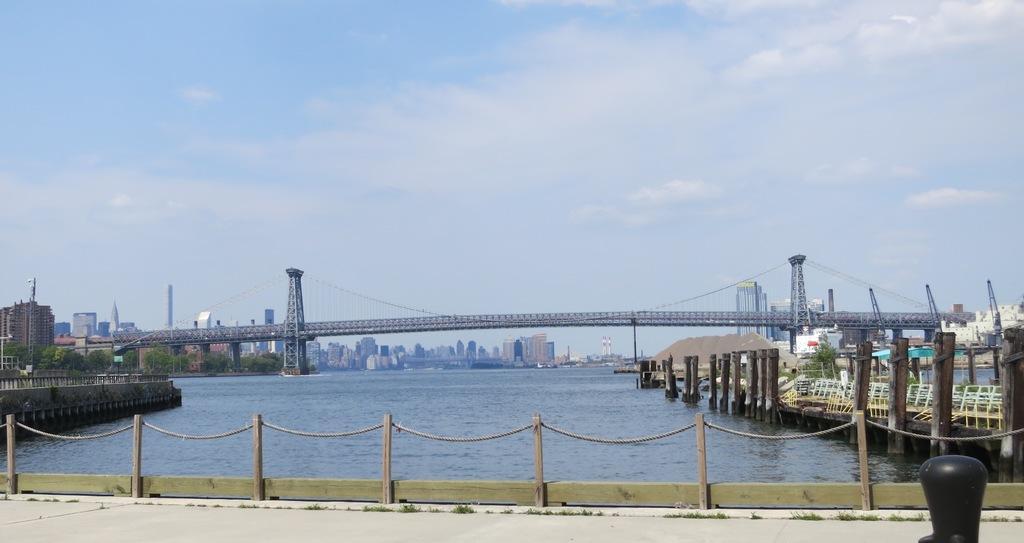In one or two sentences, can you explain what this image depicts? In the center of the image we can see a bridge in the water. In the foreground we can see a group of poles and ropes. In the background, we can see a group of cranes, trees, buildings and cloudy sky. 